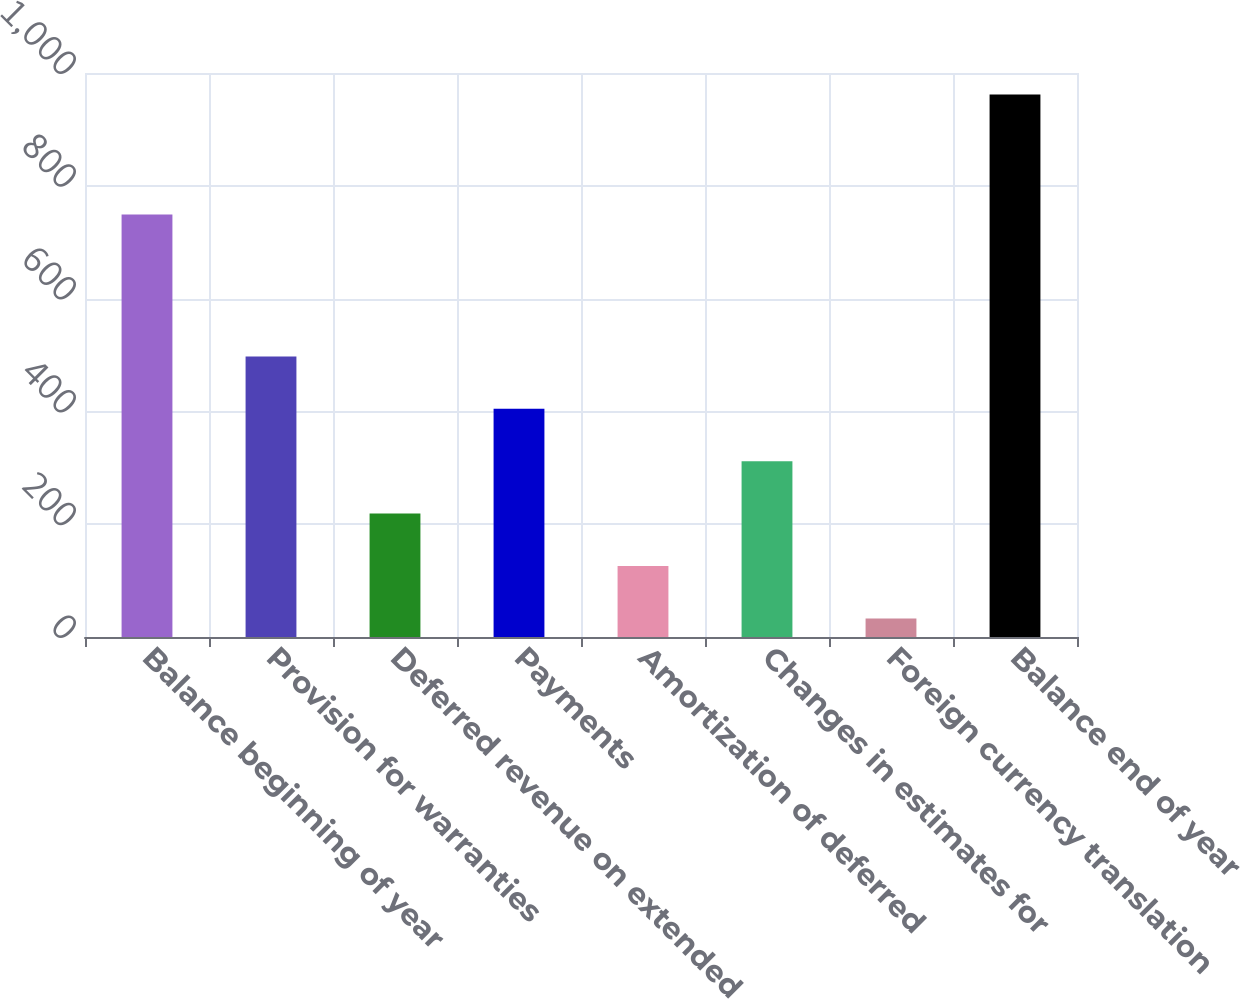<chart> <loc_0><loc_0><loc_500><loc_500><bar_chart><fcel>Balance beginning of year<fcel>Provision for warranties<fcel>Deferred revenue on extended<fcel>Payments<fcel>Amortization of deferred<fcel>Changes in estimates for<fcel>Foreign currency translation<fcel>Balance end of year<nl><fcel>749<fcel>497.5<fcel>218.8<fcel>404.6<fcel>125.9<fcel>311.7<fcel>33<fcel>962<nl></chart> 